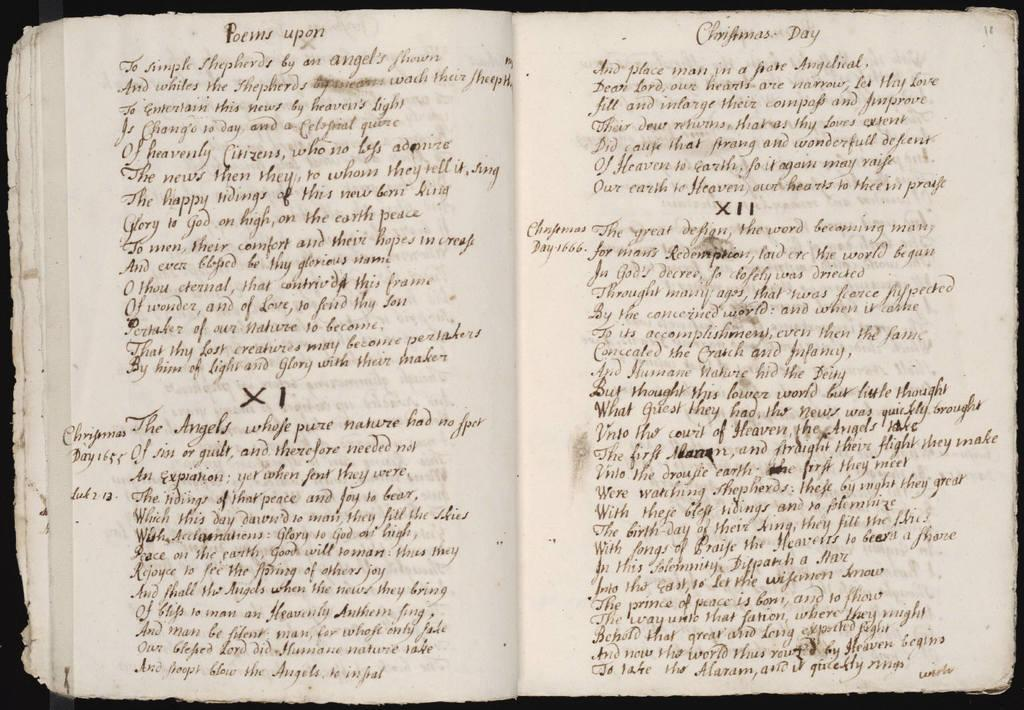What object is present in the image? There is a book in the image. What can be found within the book? The book contains text. What is the chance of finding a banana inside the book? There is no chance of finding a banana inside the book, as it contains text and not physical objects like fruit. 